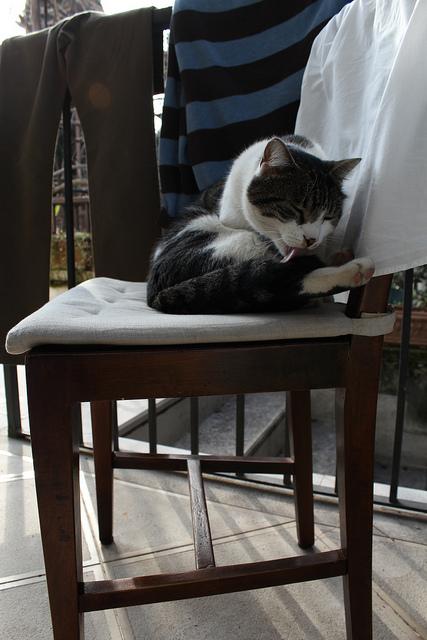What pattern in on the shirt behind the cat?
Answer briefly. Striped. What is the cat doing on the chair?
Be succinct. Cleaning itself. What is the cat doing?
Be succinct. Cleaning itself. 